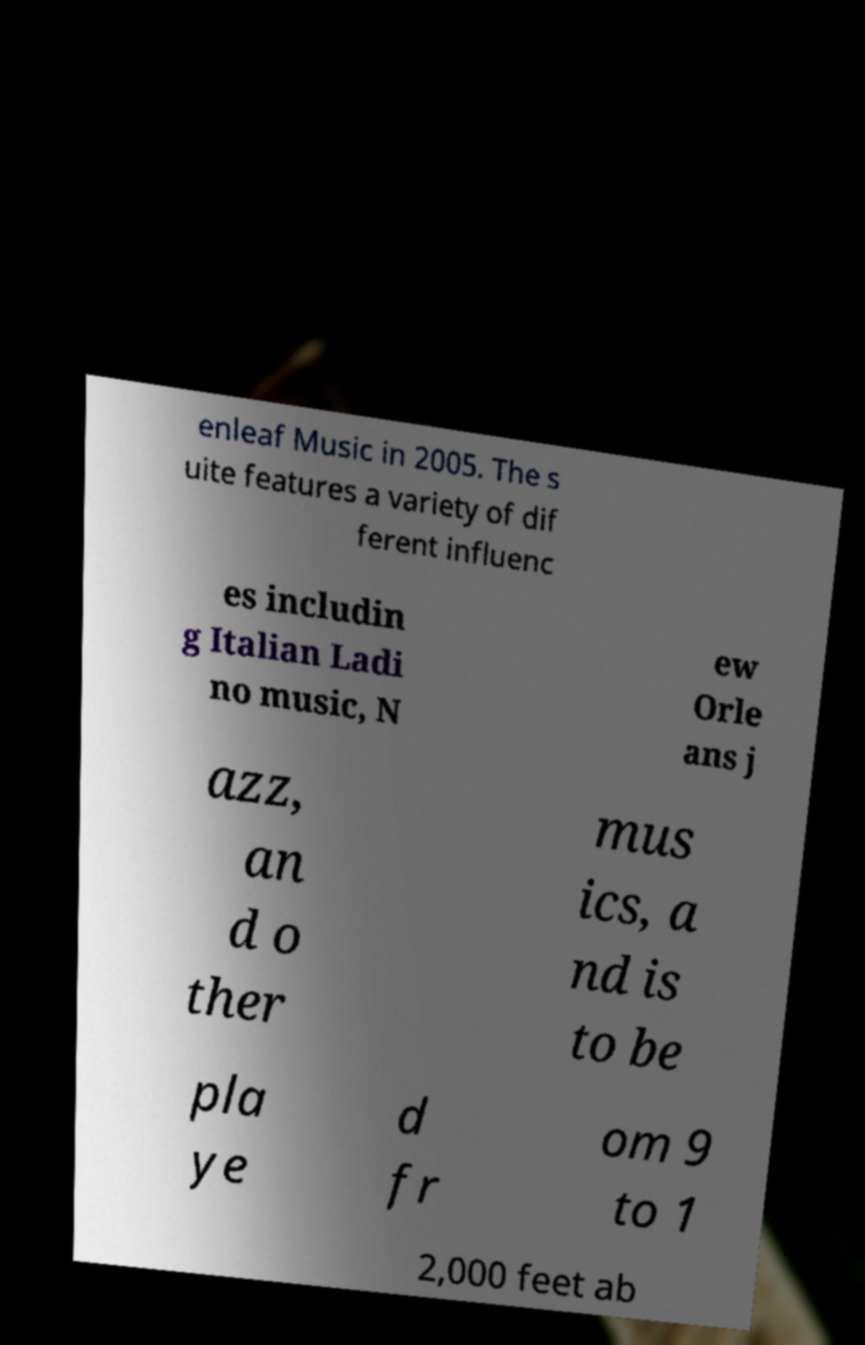Please identify and transcribe the text found in this image. enleaf Music in 2005. The s uite features a variety of dif ferent influenc es includin g Italian Ladi no music, N ew Orle ans j azz, an d o ther mus ics, a nd is to be pla ye d fr om 9 to 1 2,000 feet ab 